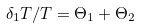<formula> <loc_0><loc_0><loc_500><loc_500>\delta _ { 1 } T / T = \Theta _ { 1 } + \Theta _ { 2 }</formula> 